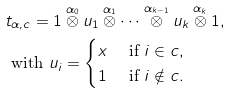Convert formula to latex. <formula><loc_0><loc_0><loc_500><loc_500>& t _ { \alpha , c } = 1 \overset { \alpha _ { 0 } } \otimes u _ { 1 } \overset { \alpha _ { 1 } } \otimes \cdots \overset { \alpha _ { k - 1 } } \otimes u _ { k } \overset { \alpha _ { k } } \otimes 1 , \\ & \text { with } u _ { i } = \begin{cases} x & \text { if } i \in c , \\ 1 & \text { if } i \notin c . \end{cases}</formula> 